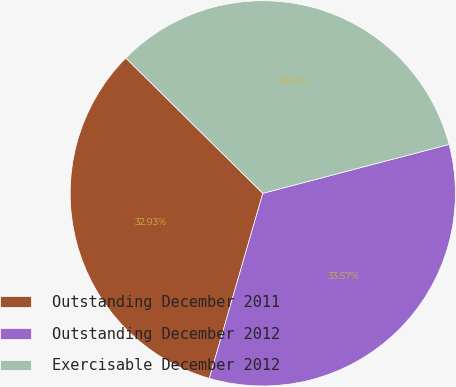Convert chart to OTSL. <chart><loc_0><loc_0><loc_500><loc_500><pie_chart><fcel>Outstanding December 2011<fcel>Outstanding December 2012<fcel>Exercisable December 2012<nl><fcel>32.93%<fcel>33.57%<fcel>33.51%<nl></chart> 